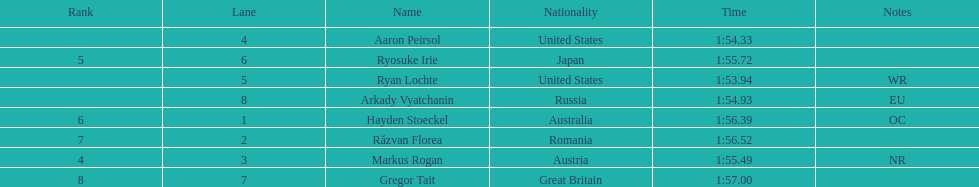How long did it take ryosuke irie to finish? 1:55.72. 